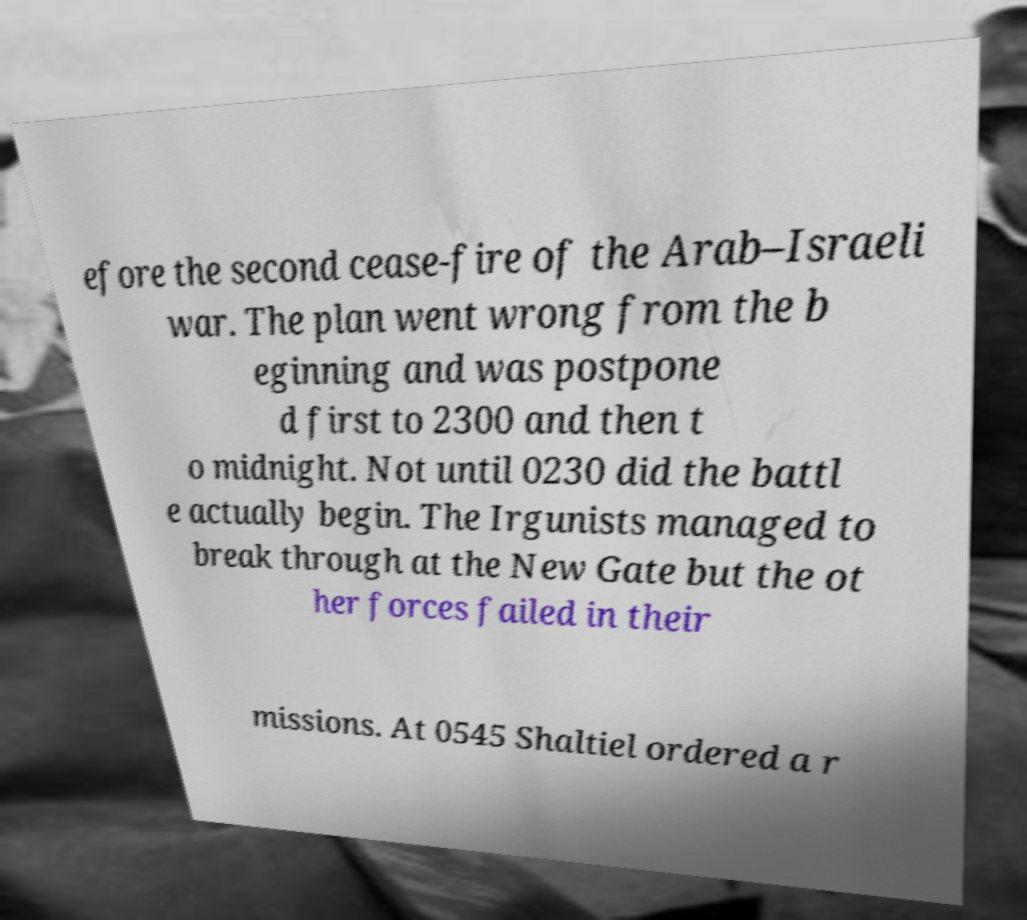Please identify and transcribe the text found in this image. efore the second cease-fire of the Arab–Israeli war. The plan went wrong from the b eginning and was postpone d first to 2300 and then t o midnight. Not until 0230 did the battl e actually begin. The Irgunists managed to break through at the New Gate but the ot her forces failed in their missions. At 0545 Shaltiel ordered a r 